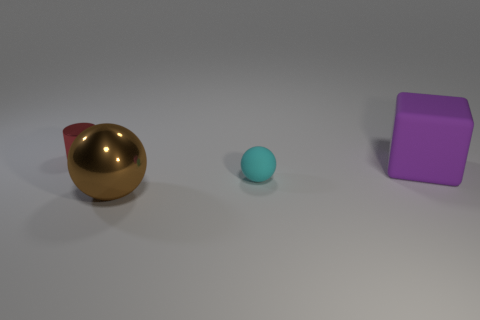Subtract 1 balls. How many balls are left? 1 Add 3 tiny green objects. How many objects exist? 7 Subtract all brown balls. How many balls are left? 1 Subtract 0 gray balls. How many objects are left? 4 Subtract all cylinders. How many objects are left? 3 Subtract all gray cylinders. Subtract all purple spheres. How many cylinders are left? 1 Subtract all large blue rubber cylinders. Subtract all brown spheres. How many objects are left? 3 Add 2 big purple rubber objects. How many big purple rubber objects are left? 3 Add 2 small cylinders. How many small cylinders exist? 3 